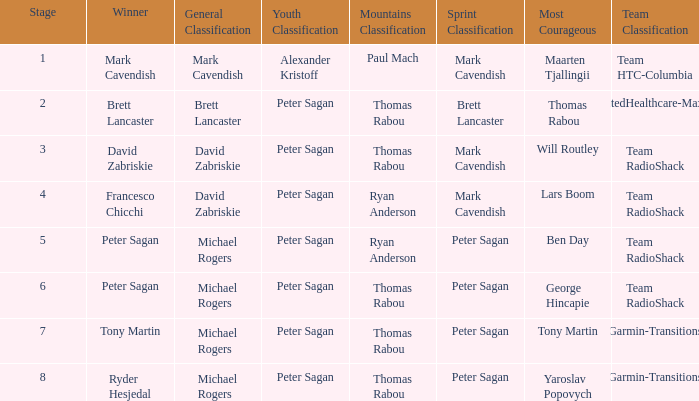Give me the full table as a dictionary. {'header': ['Stage', 'Winner', 'General Classification', 'Youth Classification', 'Mountains Classification', 'Sprint Classification', 'Most Courageous', 'Team Classification'], 'rows': [['1', 'Mark Cavendish', 'Mark Cavendish', 'Alexander Kristoff', 'Paul Mach', 'Mark Cavendish', 'Maarten Tjallingii', 'Team HTC-Columbia'], ['2', 'Brett Lancaster', 'Brett Lancaster', 'Peter Sagan', 'Thomas Rabou', 'Brett Lancaster', 'Thomas Rabou', 'UnitedHealthcare-Maxxis'], ['3', 'David Zabriskie', 'David Zabriskie', 'Peter Sagan', 'Thomas Rabou', 'Mark Cavendish', 'Will Routley', 'Team RadioShack'], ['4', 'Francesco Chicchi', 'David Zabriskie', 'Peter Sagan', 'Ryan Anderson', 'Mark Cavendish', 'Lars Boom', 'Team RadioShack'], ['5', 'Peter Sagan', 'Michael Rogers', 'Peter Sagan', 'Ryan Anderson', 'Peter Sagan', 'Ben Day', 'Team RadioShack'], ['6', 'Peter Sagan', 'Michael Rogers', 'Peter Sagan', 'Thomas Rabou', 'Peter Sagan', 'George Hincapie', 'Team RadioShack'], ['7', 'Tony Martin', 'Michael Rogers', 'Peter Sagan', 'Thomas Rabou', 'Peter Sagan', 'Tony Martin', 'Garmin-Transitions'], ['8', 'Ryder Hesjedal', 'Michael Rogers', 'Peter Sagan', 'Thomas Rabou', 'Peter Sagan', 'Yaroslav Popovych', 'Garmin-Transitions']]} Who won the mountains classification when Maarten Tjallingii won most corageous? Paul Mach. 